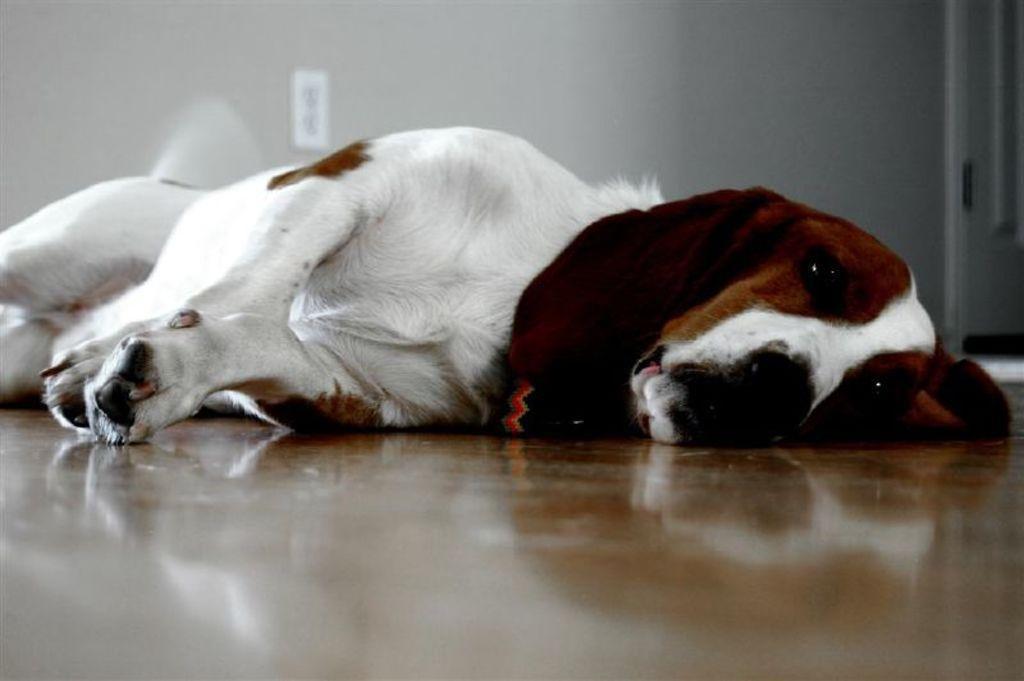Describe this image in one or two sentences. In this image, we can see a dog is laying on the surface. Background we can see a wall, switchboard and door. 